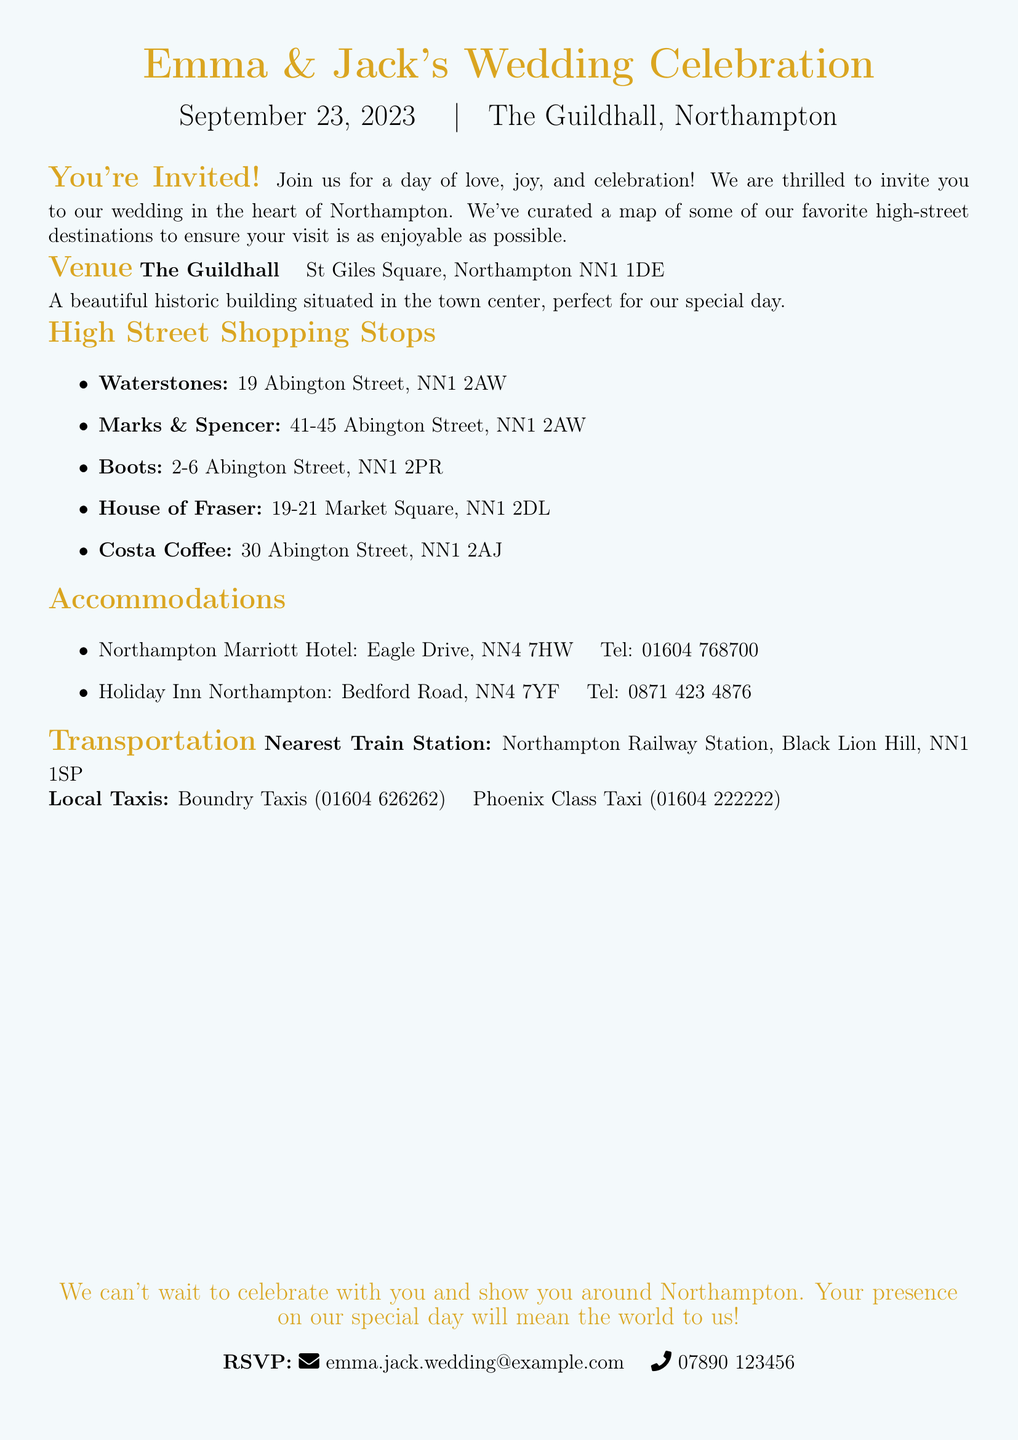What date is the wedding? The document states the wedding date clearly in the introductory section as September 23, 2023.
Answer: September 23, 2023 What is the venue of the wedding? The invite lists the wedding venue as The Guildhall, located in the town center.
Answer: The Guildhall Where is Waterstones located? The document provides a specific address for Waterstones, which is listed under High Street Shopping Stops.
Answer: 19 Abington Street, NN1 2AW What is the contact number for Northampton Marriott Hotel? The invite includes the contact information for accommodations, and the number for Northampton Marriott Hotel is specified.
Answer: 01604 768700 How many shopping stops are listed? The High Street Shopping Stops section enumerates five specific shops for guests.
Answer: Five What is the purpose of the map mentioned in the invitation? The purpose of the map is to guide guests to some favorite high-street destinations during their visit.
Answer: To guide guests to high-street destinations What should guests do to RSVP? The invitation provides clear instructions for guests on how to respond regarding their attendance.
Answer: Email or call Which coffee shop is mentioned in the invitation? Among the High Street Shopping Stops, Costa Coffee is specifically named in the document.
Answer: Costa Coffee 